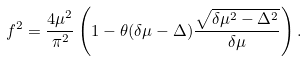<formula> <loc_0><loc_0><loc_500><loc_500>f ^ { 2 } = \frac { 4 \mu ^ { 2 } } { \pi ^ { 2 } } \left ( 1 - \theta ( \delta \mu - \Delta ) \frac { \sqrt { \delta \mu ^ { 2 } - \Delta ^ { 2 } } } { \delta \mu } \right ) .</formula> 